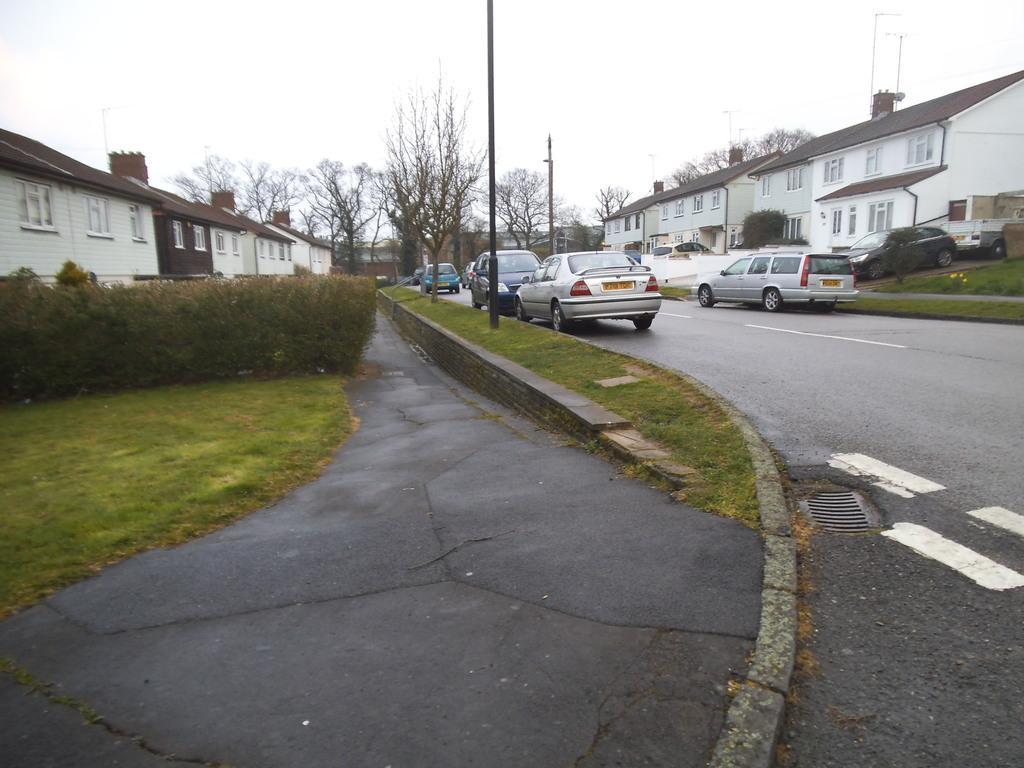Please provide a concise description of this image. In this image we can see a few vehicles on the road and there are some buildings. We can see some plants and trees and there are two poles and at the top we can see the sky. 